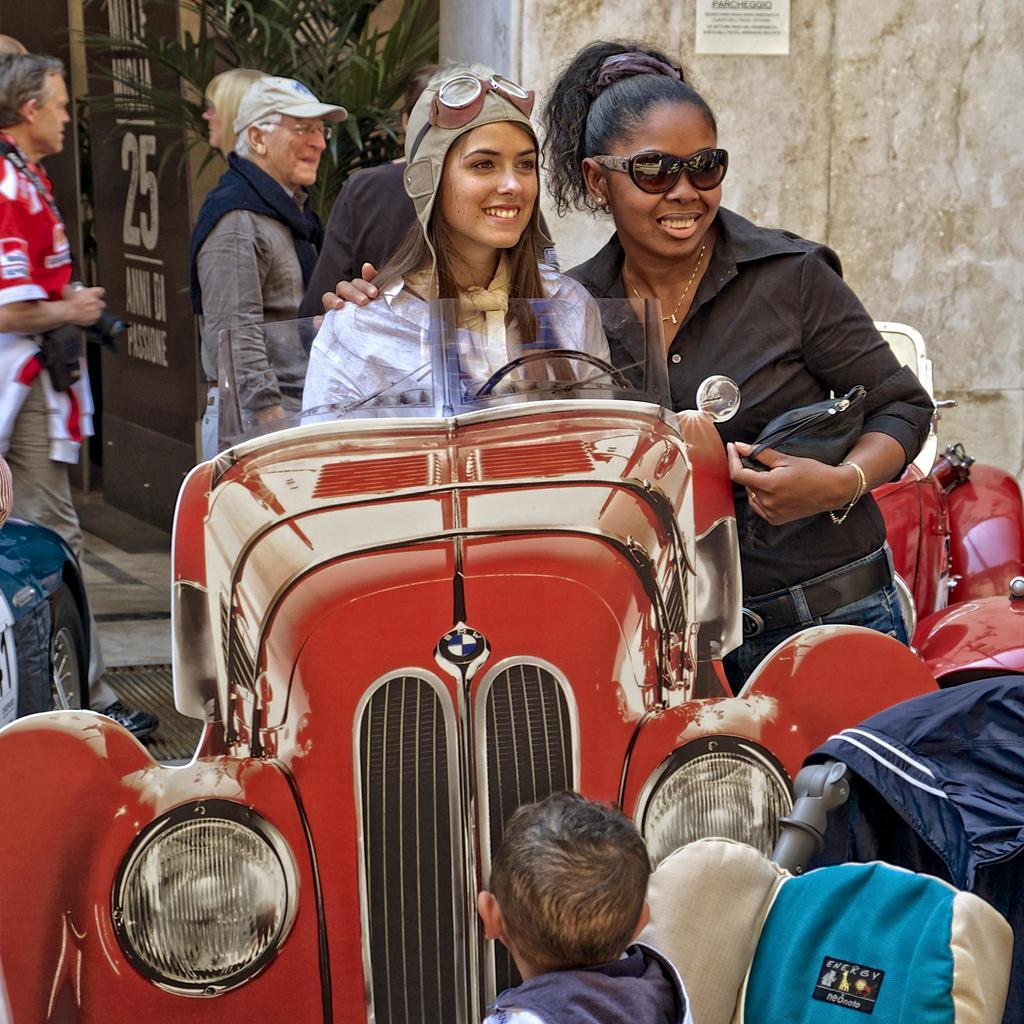How many people are present in the image? There are many people in the image. Can you describe the interaction between two people in the image? Two people are standing near a vintage car. What type of vegetation can be seen in the image? There are plants visible in the image. What type of music is being played by the cow in the image? There is no cow present in the image, and therefore no music being played by a cow. 